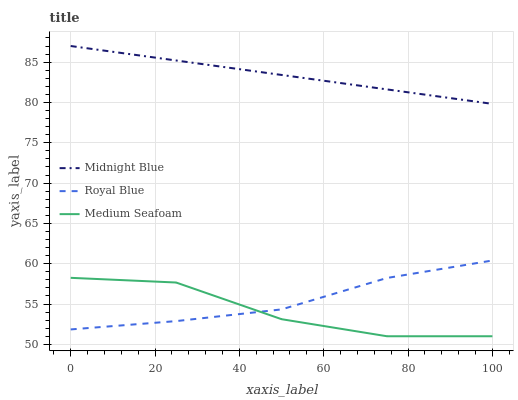Does Medium Seafoam have the minimum area under the curve?
Answer yes or no. Yes. Does Midnight Blue have the maximum area under the curve?
Answer yes or no. Yes. Does Midnight Blue have the minimum area under the curve?
Answer yes or no. No. Does Medium Seafoam have the maximum area under the curve?
Answer yes or no. No. Is Midnight Blue the smoothest?
Answer yes or no. Yes. Is Medium Seafoam the roughest?
Answer yes or no. Yes. Is Medium Seafoam the smoothest?
Answer yes or no. No. Is Midnight Blue the roughest?
Answer yes or no. No. Does Medium Seafoam have the lowest value?
Answer yes or no. Yes. Does Midnight Blue have the lowest value?
Answer yes or no. No. Does Midnight Blue have the highest value?
Answer yes or no. Yes. Does Medium Seafoam have the highest value?
Answer yes or no. No. Is Royal Blue less than Midnight Blue?
Answer yes or no. Yes. Is Midnight Blue greater than Medium Seafoam?
Answer yes or no. Yes. Does Medium Seafoam intersect Royal Blue?
Answer yes or no. Yes. Is Medium Seafoam less than Royal Blue?
Answer yes or no. No. Is Medium Seafoam greater than Royal Blue?
Answer yes or no. No. Does Royal Blue intersect Midnight Blue?
Answer yes or no. No. 